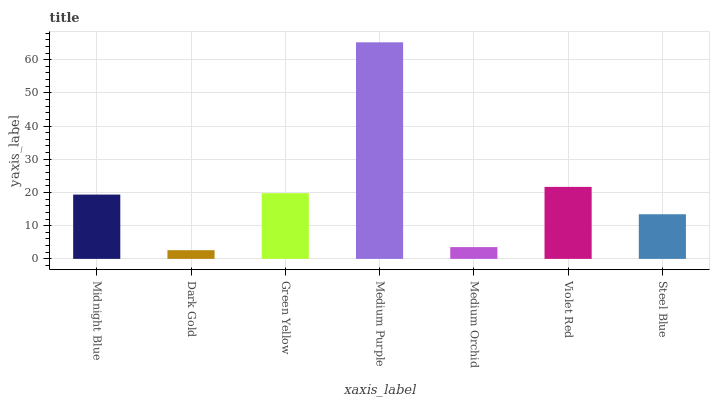Is Green Yellow the minimum?
Answer yes or no. No. Is Green Yellow the maximum?
Answer yes or no. No. Is Green Yellow greater than Dark Gold?
Answer yes or no. Yes. Is Dark Gold less than Green Yellow?
Answer yes or no. Yes. Is Dark Gold greater than Green Yellow?
Answer yes or no. No. Is Green Yellow less than Dark Gold?
Answer yes or no. No. Is Midnight Blue the high median?
Answer yes or no. Yes. Is Midnight Blue the low median?
Answer yes or no. Yes. Is Medium Purple the high median?
Answer yes or no. No. Is Medium Purple the low median?
Answer yes or no. No. 